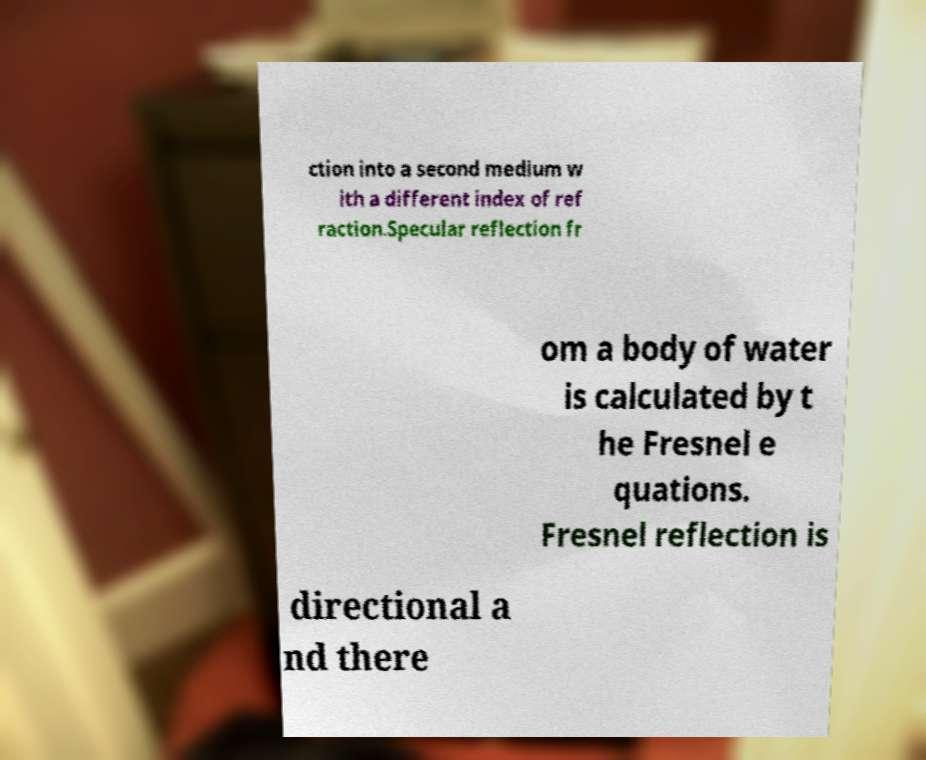Please identify and transcribe the text found in this image. ction into a second medium w ith a different index of ref raction.Specular reflection fr om a body of water is calculated by t he Fresnel e quations. Fresnel reflection is directional a nd there 